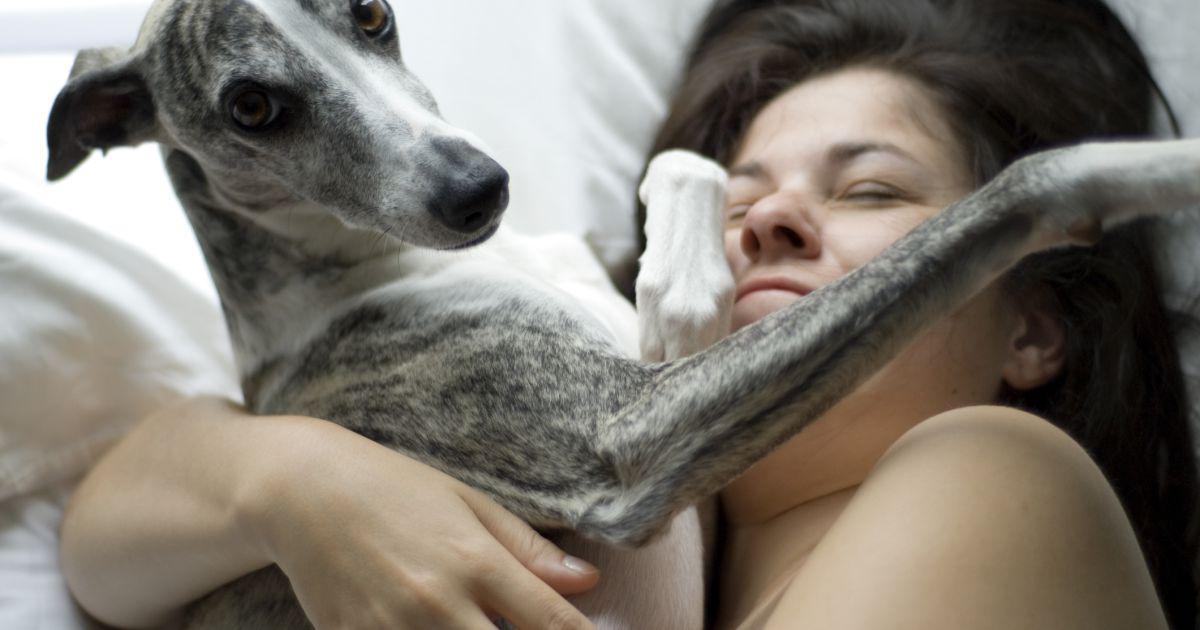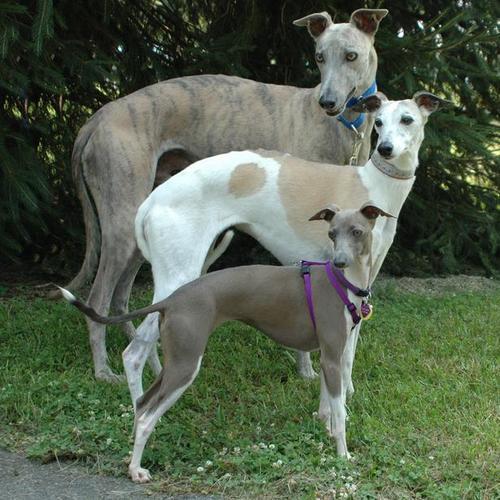The first image is the image on the left, the second image is the image on the right. Considering the images on both sides, is "Three hounds with heads turned in the same direction, pose standing next to one another, in ascending size order." valid? Answer yes or no. Yes. The first image is the image on the left, the second image is the image on the right. For the images displayed, is the sentence "There is exactly three dogs in the right image." factually correct? Answer yes or no. Yes. 